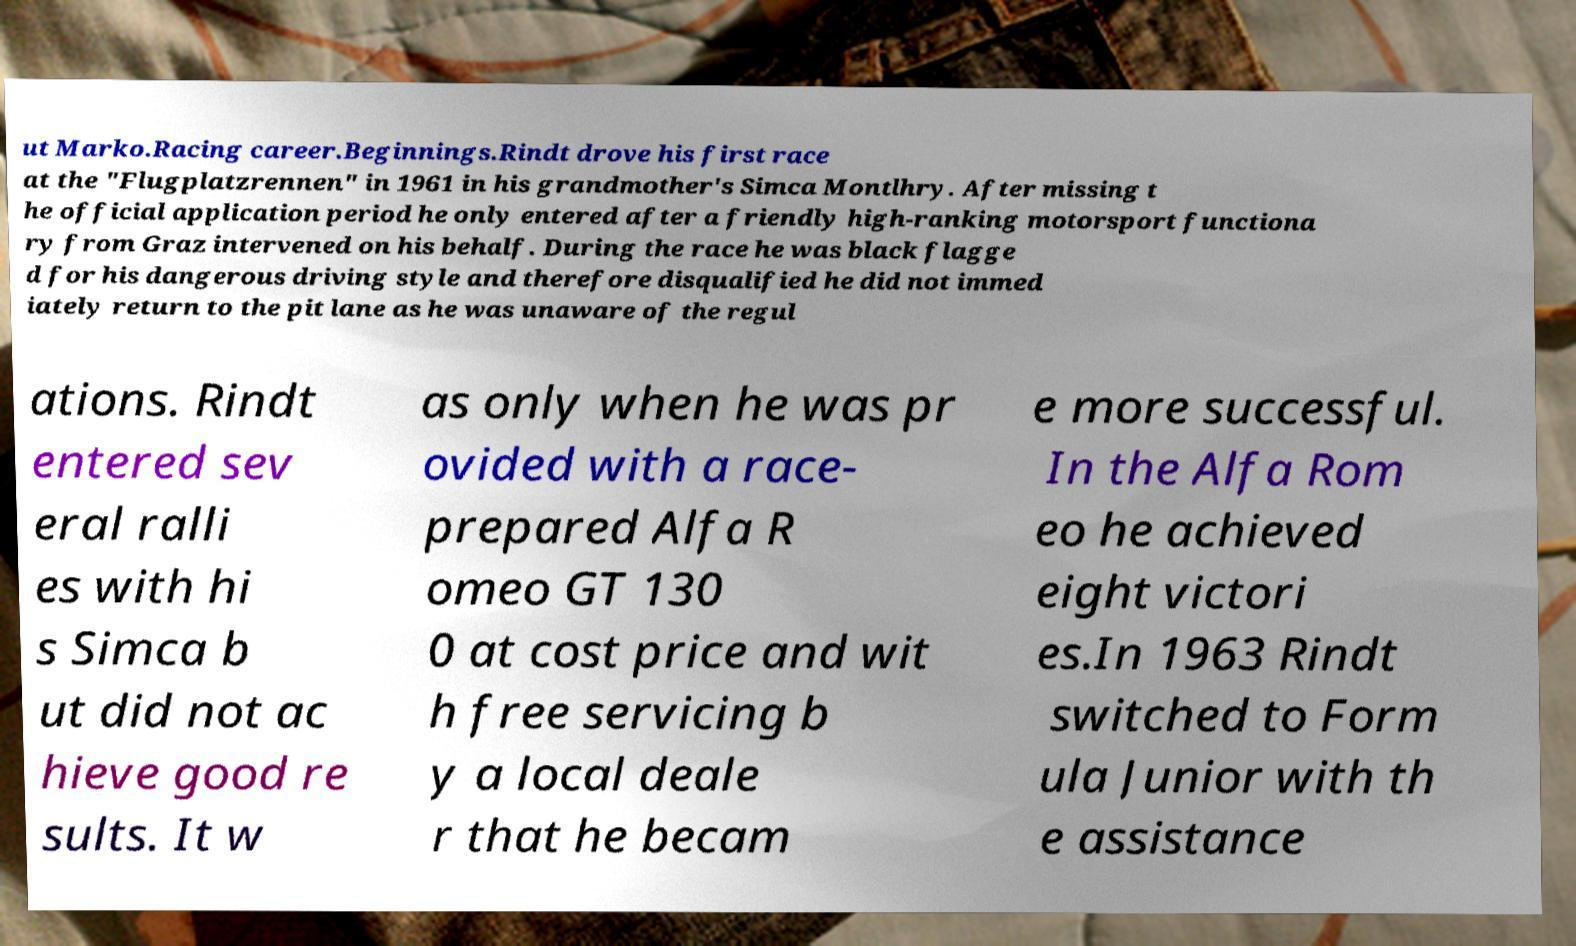What messages or text are displayed in this image? I need them in a readable, typed format. ut Marko.Racing career.Beginnings.Rindt drove his first race at the "Flugplatzrennen" in 1961 in his grandmother's Simca Montlhry. After missing t he official application period he only entered after a friendly high-ranking motorsport functiona ry from Graz intervened on his behalf. During the race he was black flagge d for his dangerous driving style and therefore disqualified he did not immed iately return to the pit lane as he was unaware of the regul ations. Rindt entered sev eral ralli es with hi s Simca b ut did not ac hieve good re sults. It w as only when he was pr ovided with a race- prepared Alfa R omeo GT 130 0 at cost price and wit h free servicing b y a local deale r that he becam e more successful. In the Alfa Rom eo he achieved eight victori es.In 1963 Rindt switched to Form ula Junior with th e assistance 